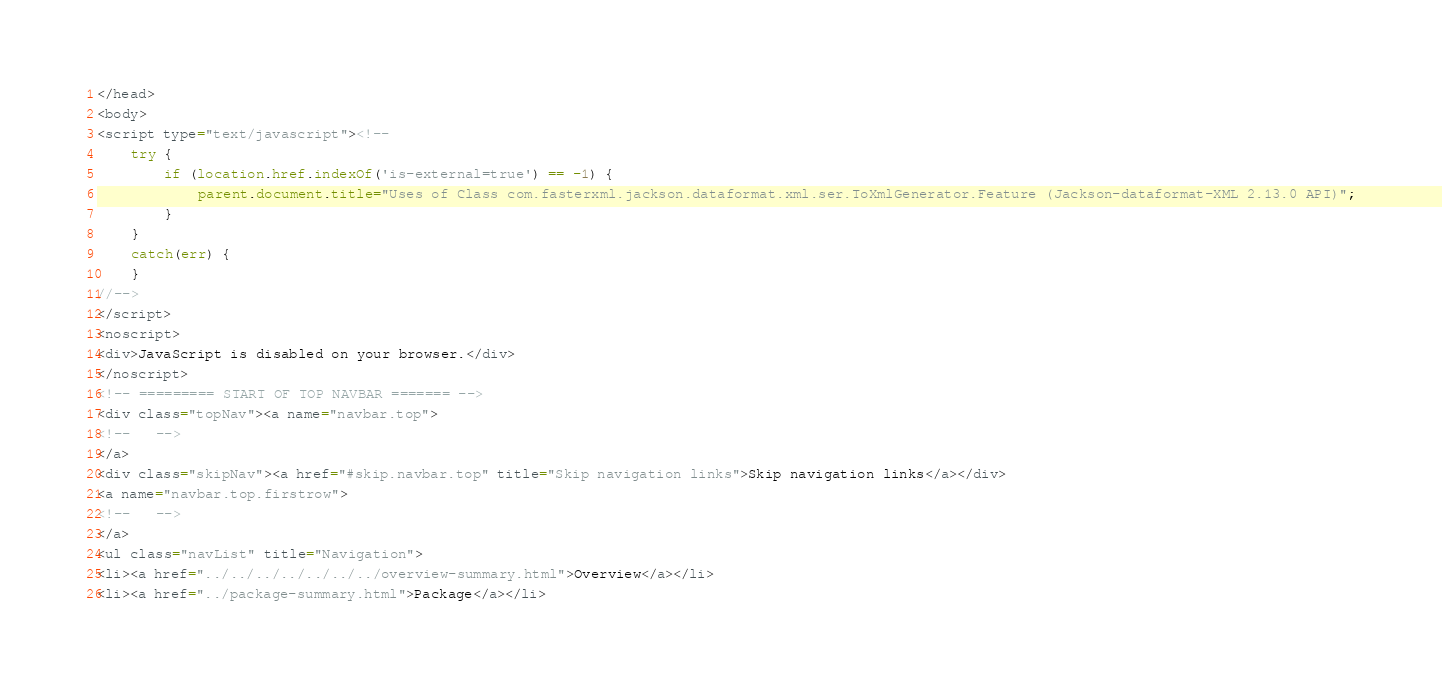<code> <loc_0><loc_0><loc_500><loc_500><_HTML_></head>
<body>
<script type="text/javascript"><!--
    try {
        if (location.href.indexOf('is-external=true') == -1) {
            parent.document.title="Uses of Class com.fasterxml.jackson.dataformat.xml.ser.ToXmlGenerator.Feature (Jackson-dataformat-XML 2.13.0 API)";
        }
    }
    catch(err) {
    }
//-->
</script>
<noscript>
<div>JavaScript is disabled on your browser.</div>
</noscript>
<!-- ========= START OF TOP NAVBAR ======= -->
<div class="topNav"><a name="navbar.top">
<!--   -->
</a>
<div class="skipNav"><a href="#skip.navbar.top" title="Skip navigation links">Skip navigation links</a></div>
<a name="navbar.top.firstrow">
<!--   -->
</a>
<ul class="navList" title="Navigation">
<li><a href="../../../../../../../overview-summary.html">Overview</a></li>
<li><a href="../package-summary.html">Package</a></li></code> 